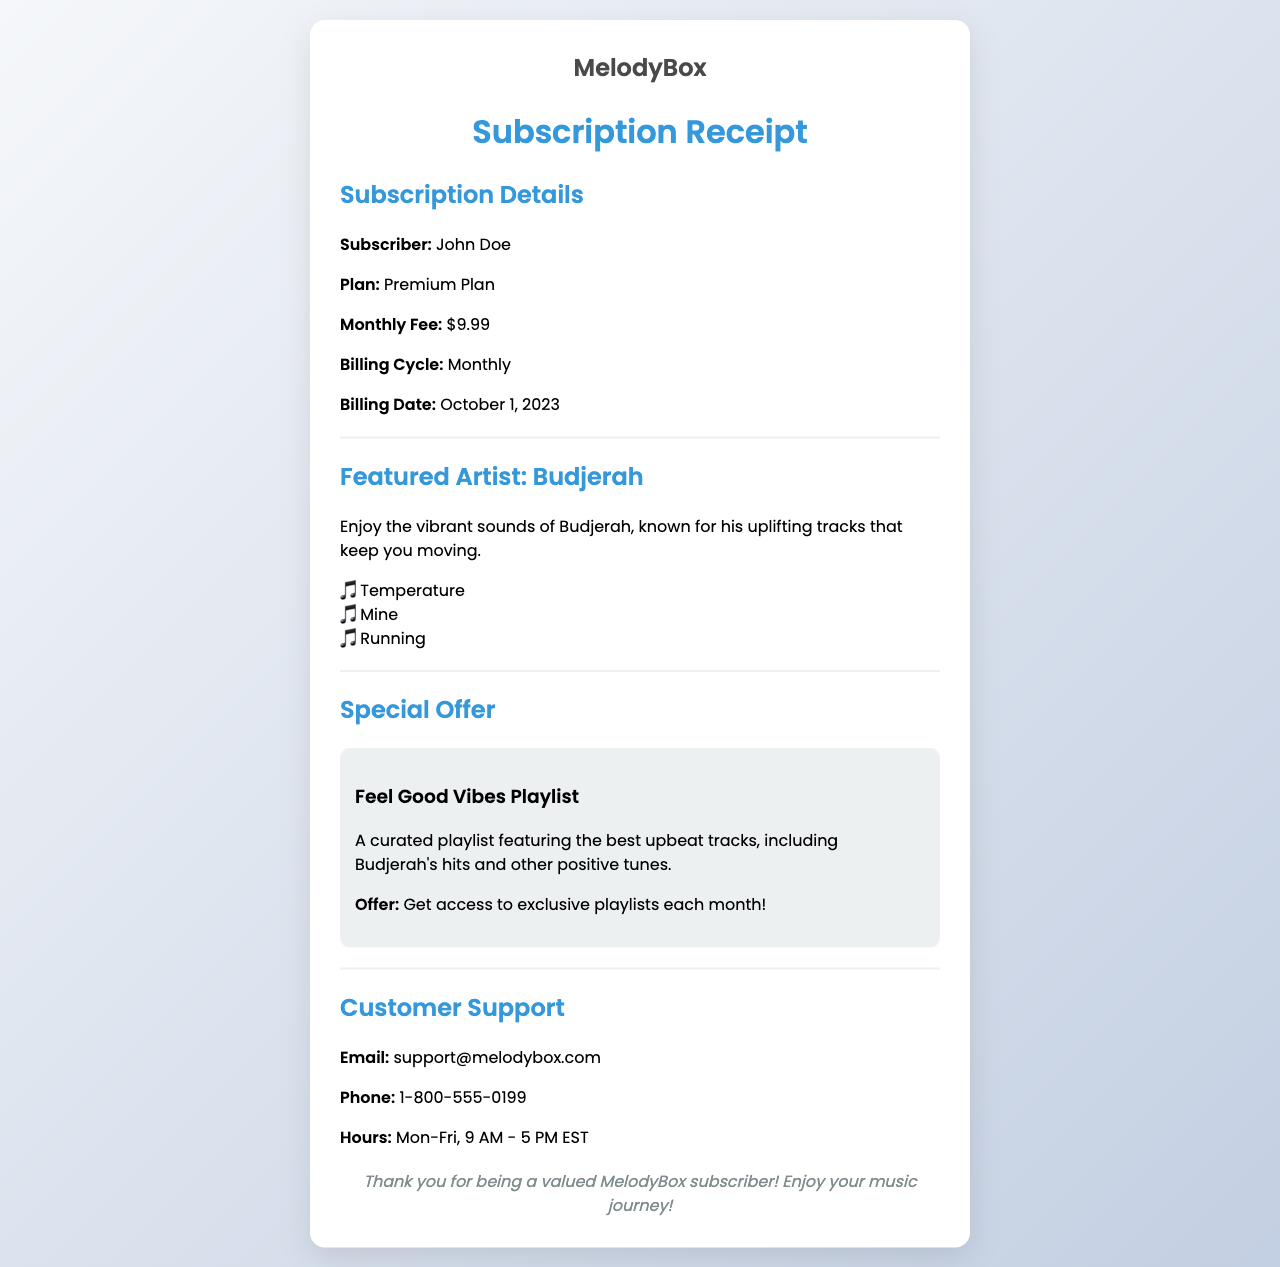What is the subscriber's name? The subscriber's name is provided in the subscription details section of the document.
Answer: John Doe What is the monthly fee for the subscription? The monthly fee is explicitly stated in the subscription details.
Answer: $9.99 What date is the billing cycle for the subscription? The billing date is specified in the subscription details.
Answer: October 1, 2023 Who is the featured artist in this receipt? The document highlights Budjerah as the featured artist.
Answer: Budjerah What does the special offer provide? The special offer details that a curated playlist is available, along with exclusive access.
Answer: Access to exclusive playlists each month How many tracks are listed under the featured artist? The number of tracks mentioned for Budjerah indicates how many songs are listed.
Answer: 3 What is the purpose of the Customer Support section? The customer support section provides assistance and contact information for subscribers.
Answer: Assistance and contact information What is the name of the curated playlist mentioned? The curated playlist is named in the special offers section.
Answer: Feel Good Vibes Playlist What type of plan is the subscription? The type of plan is mentioned in the subscription details.
Answer: Premium Plan 